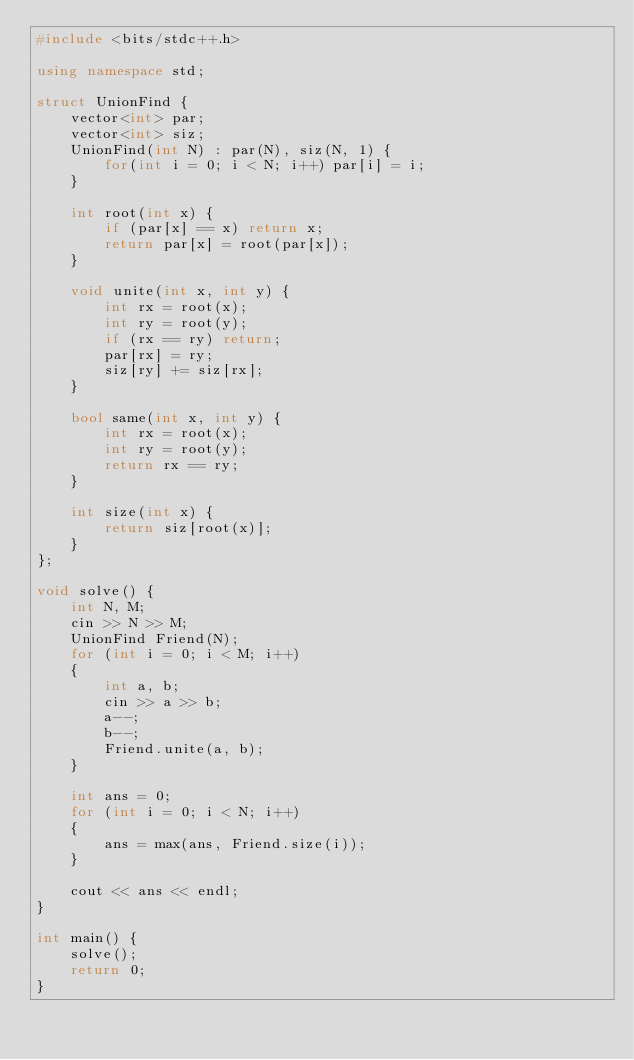Convert code to text. <code><loc_0><loc_0><loc_500><loc_500><_C++_>#include <bits/stdc++.h>

using namespace std;

struct UnionFind {
    vector<int> par;
    vector<int> siz;
    UnionFind(int N) : par(N), siz(N, 1) {
        for(int i = 0; i < N; i++) par[i] = i;
    }

    int root(int x) {
        if (par[x] == x) return x;
        return par[x] = root(par[x]);
    }

    void unite(int x, int y) {
        int rx = root(x);
        int ry = root(y);
        if (rx == ry) return;
        par[rx] = ry;
        siz[ry] += siz[rx];
    }

    bool same(int x, int y) {
        int rx = root(x);
        int ry = root(y);
        return rx == ry;
    }

    int size(int x) {
        return siz[root(x)];
    }
};

void solve() {
    int N, M;
    cin >> N >> M;
    UnionFind Friend(N);
    for (int i = 0; i < M; i++)
    {
        int a, b;
        cin >> a >> b;
        a--;
        b--;
        Friend.unite(a, b);
    }

    int ans = 0;
    for (int i = 0; i < N; i++)
    {
        ans = max(ans, Friend.size(i));
    }
    
    cout << ans << endl;
}

int main() {
    solve();
    return 0;
}</code> 